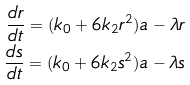Convert formula to latex. <formula><loc_0><loc_0><loc_500><loc_500>\frac { d r } { d t } = ( k _ { 0 } + 6 k _ { 2 } r ^ { 2 } ) a - \lambda r \\ \frac { d s } { d t } = ( k _ { 0 } + 6 k _ { 2 } s ^ { 2 } ) a - \lambda s</formula> 